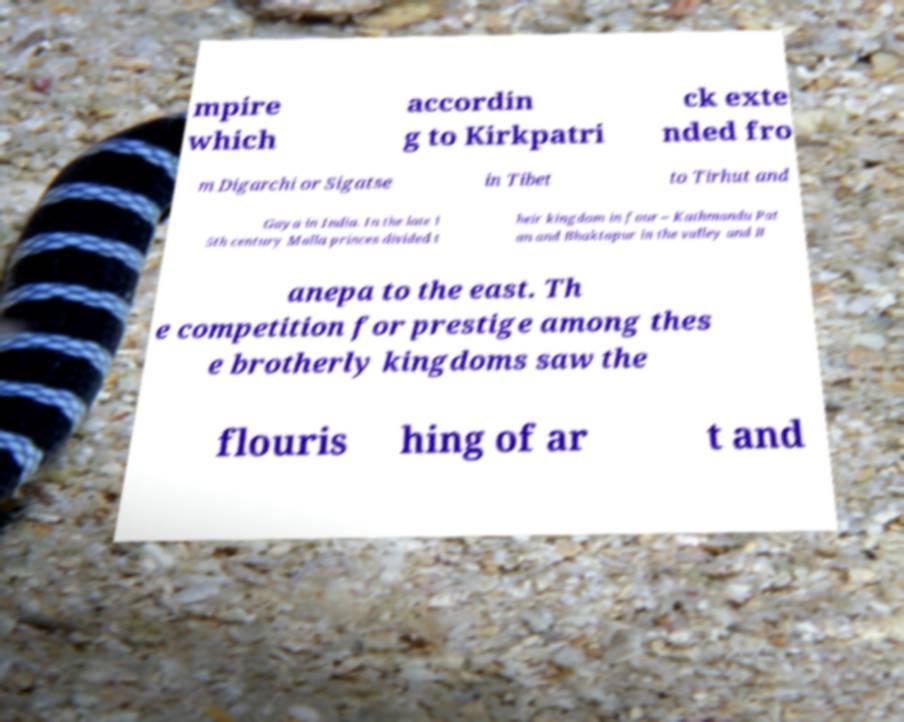Please read and relay the text visible in this image. What does it say? mpire which accordin g to Kirkpatri ck exte nded fro m Digarchi or Sigatse in Tibet to Tirhut and Gaya in India. In the late 1 5th century Malla princes divided t heir kingdom in four – Kathmandu Pat an and Bhaktapur in the valley and B anepa to the east. Th e competition for prestige among thes e brotherly kingdoms saw the flouris hing of ar t and 